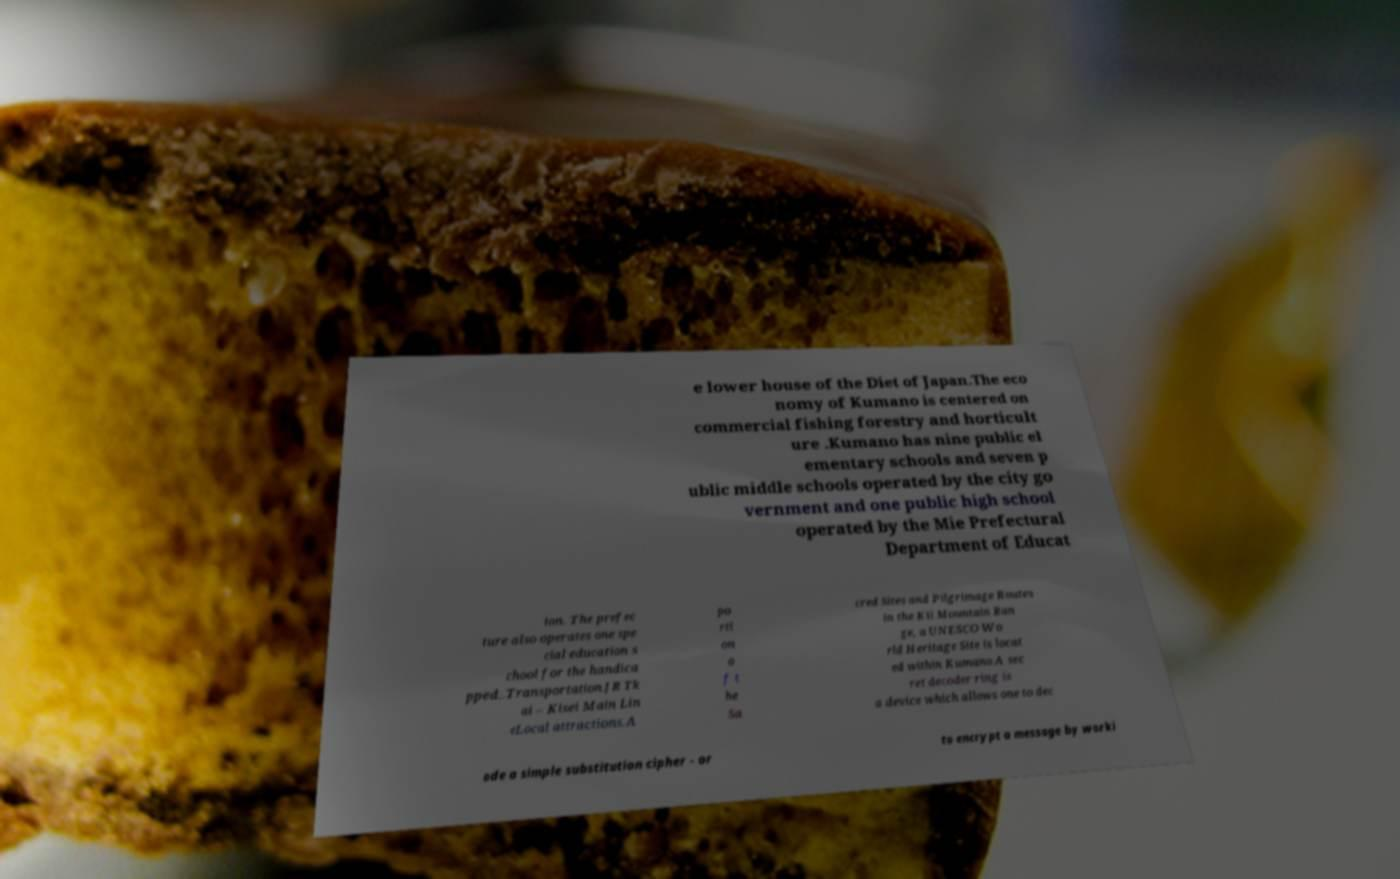For documentation purposes, I need the text within this image transcribed. Could you provide that? e lower house of the Diet of Japan.The eco nomy of Kumano is centered on commercial fishing forestry and horticult ure .Kumano has nine public el ementary schools and seven p ublic middle schools operated by the city go vernment and one public high school operated by the Mie Prefectural Department of Educat ion. The prefec ture also operates one spe cial education s chool for the handica pped..Transportation.JR Tk ai – Kisei Main Lin eLocal attractions.A po rti on o f t he Sa cred Sites and Pilgrimage Routes in the Kii Mountain Ran ge, a UNESCO Wo rld Heritage Site is locat ed within Kumano.A sec ret decoder ring is a device which allows one to dec ode a simple substitution cipher - or to encrypt a message by worki 